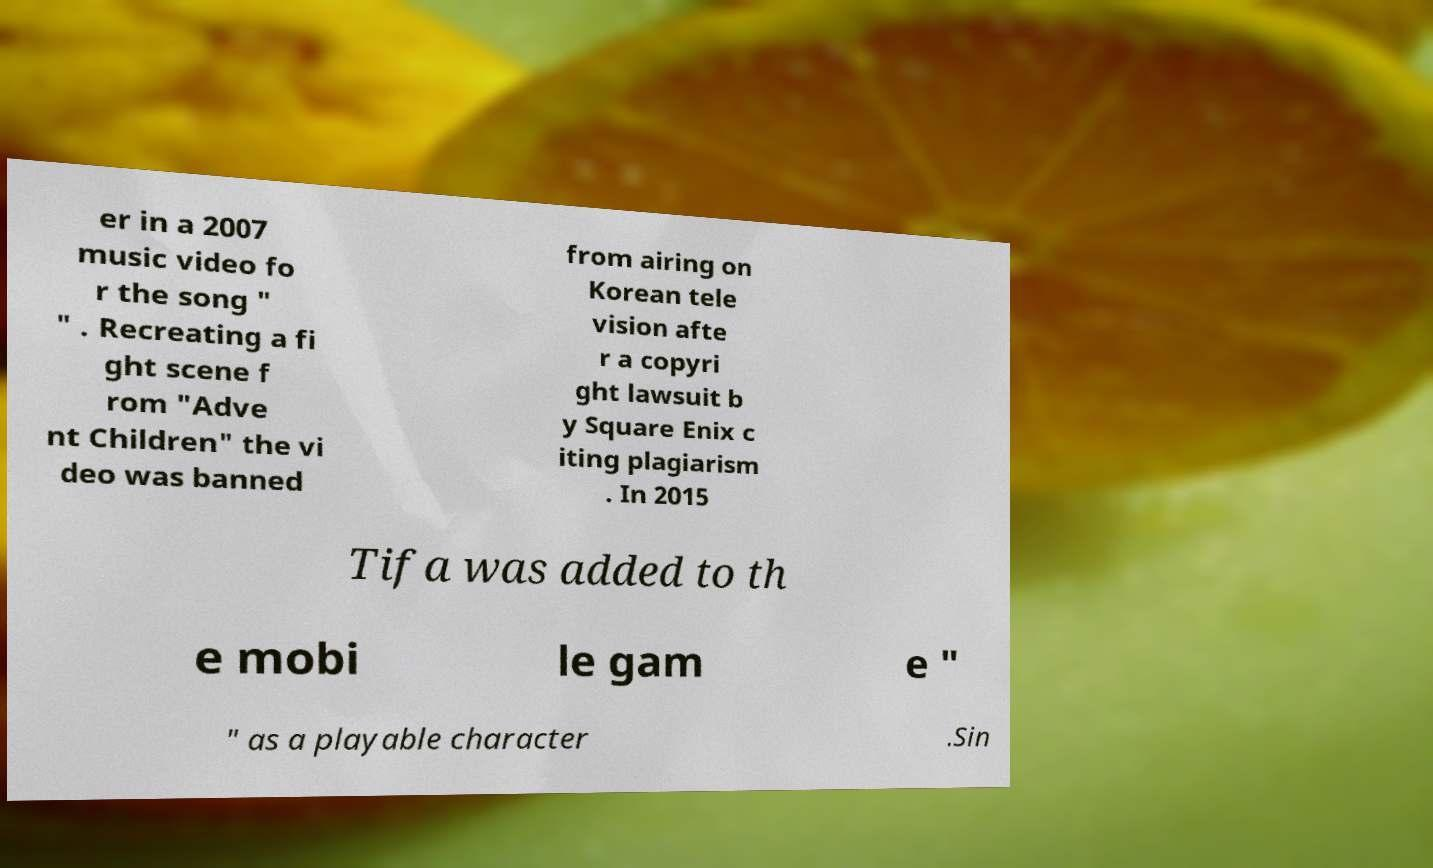Could you assist in decoding the text presented in this image and type it out clearly? er in a 2007 music video fo r the song " " . Recreating a fi ght scene f rom "Adve nt Children" the vi deo was banned from airing on Korean tele vision afte r a copyri ght lawsuit b y Square Enix c iting plagiarism . In 2015 Tifa was added to th e mobi le gam e " " as a playable character .Sin 